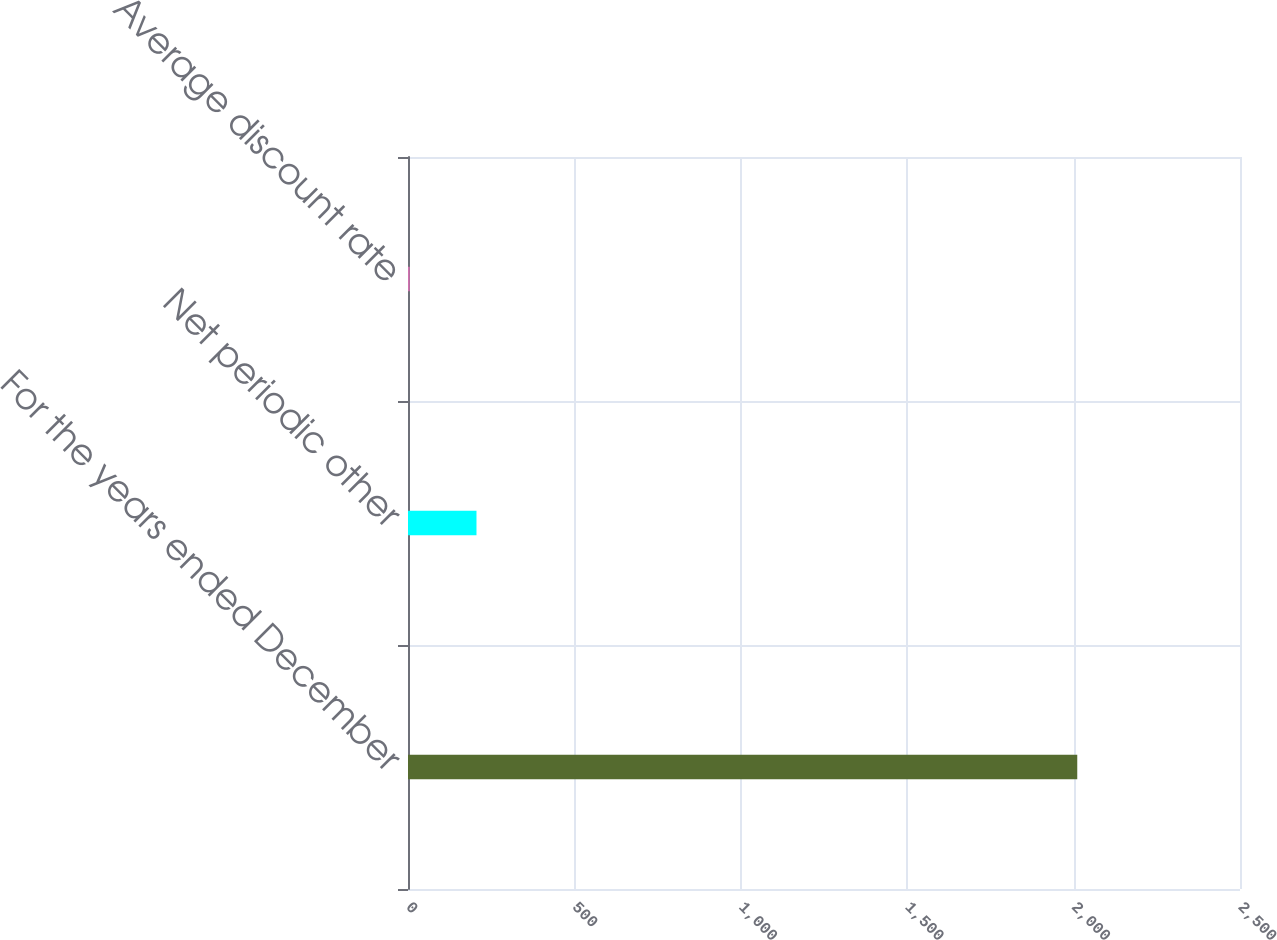<chart> <loc_0><loc_0><loc_500><loc_500><bar_chart><fcel>For the years ended December<fcel>Net periodic other<fcel>Average discount rate<nl><fcel>2011<fcel>205.78<fcel>5.2<nl></chart> 